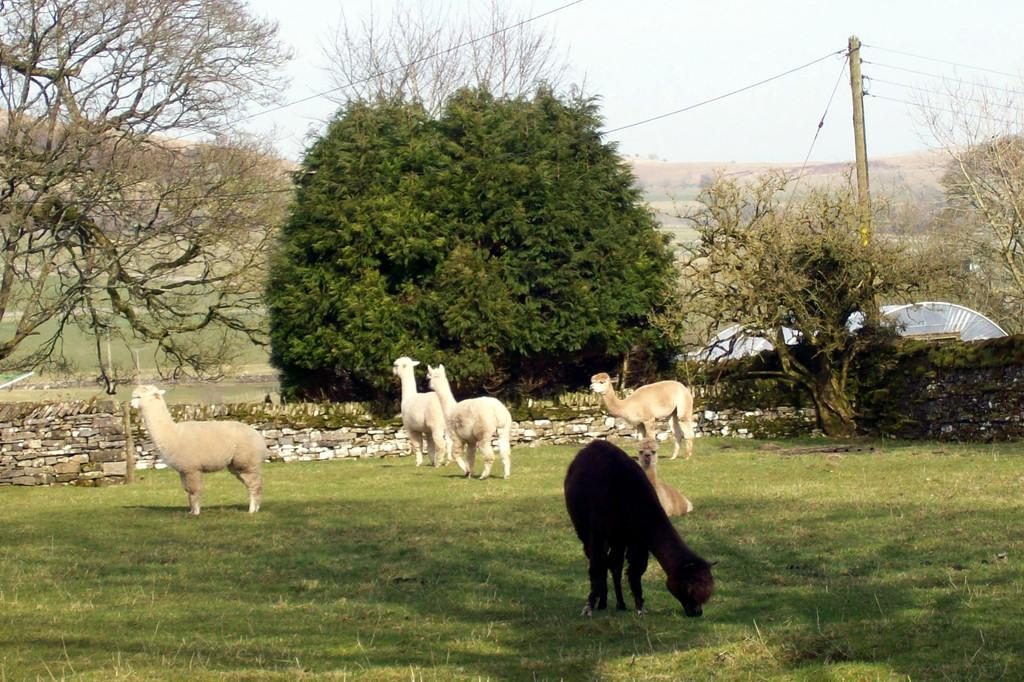What type of animals can be seen on the ground in the image? There are animals on the ground in the image. What other elements can be seen in the image besides the animals? There are stones, grass, trees, a shed, poles, and the sky visible in the image. Can you describe the natural environment in the image? The image features grass, trees, and the sky, which suggests a natural outdoor setting. What type of structure is present in the image? There is a shed in the image. How many sacks of grain are being carried by the cattle in the image? There are no cattle or sacks of grain present in the image. 